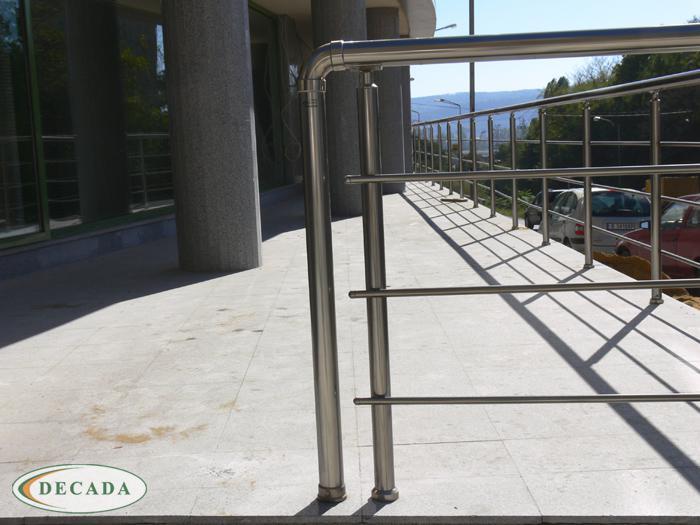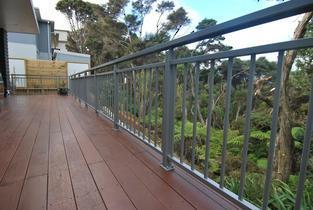The first image is the image on the left, the second image is the image on the right. For the images shown, is this caption "The right image shows a straight metal rail with vertical bars at the edge of a stained brown plank deck that overlooks dense foliage and trees." true? Answer yes or no. Yes. The first image is the image on the left, the second image is the image on the right. Evaluate the accuracy of this statement regarding the images: "In at least one image there are columns attached to the building and at least a strip of cement.". Is it true? Answer yes or no. Yes. 